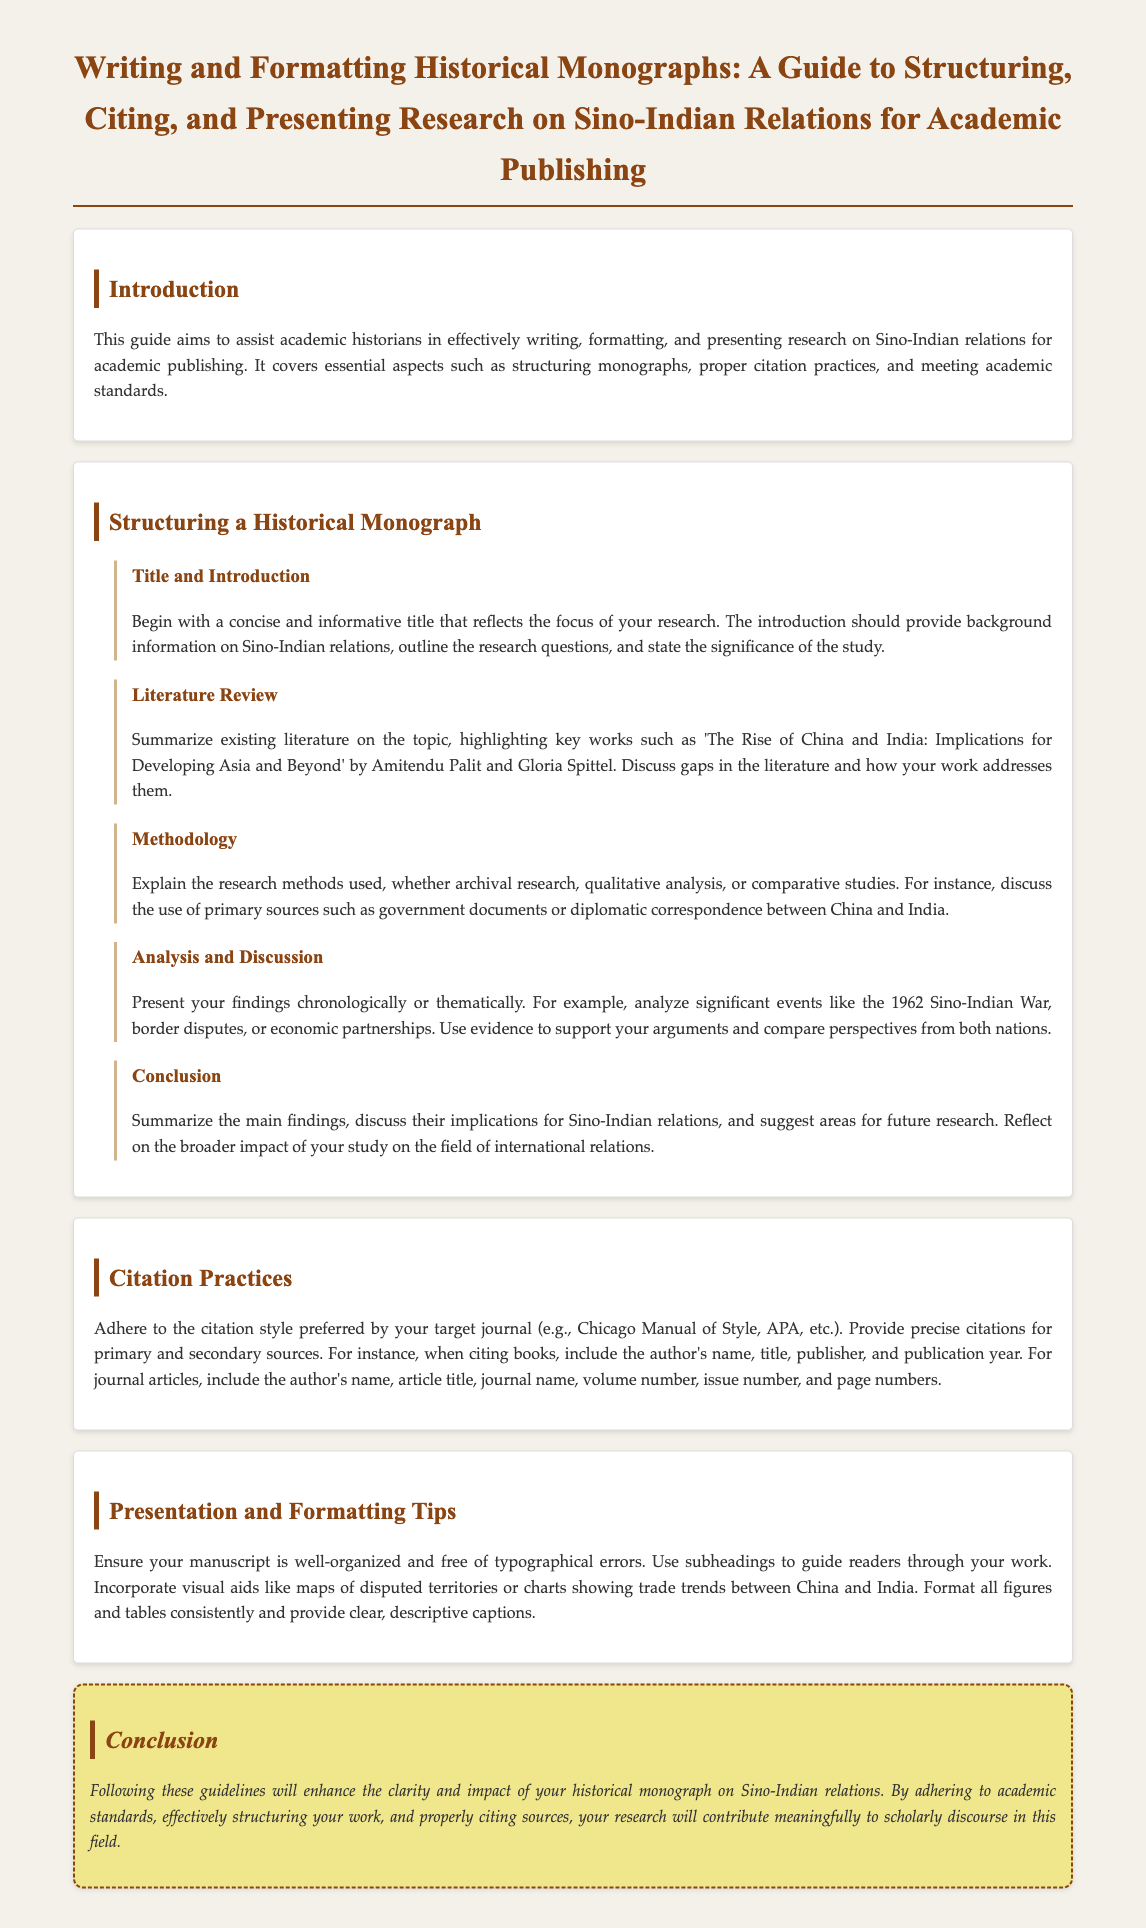What is the title of the guide? The title of the guide is prominently displayed at the top of the document and reflects the focus on historical monographs about Sino-Indian relations.
Answer: Writing and Formatting Historical Monographs: A Guide to Structuring, Citing, and Presenting Research on Sino-Indian Relations for Academic Publishing What should be included in the introduction? The introduction should provide background information on Sino-Indian relations, outline the research questions, and state the significance of the study.
Answer: Background information, research questions, significance What key work is highlighted in the literature review? The literature review summarizes existing literature and mentions a specific key work that focuses on the implications of China and India for developing Asia.
Answer: The Rise of China and India: Implications for Developing Asia and Beyond Which research methods might be discussed in the methodology section? The methodology section refers to several types of research methods used for historical monographs.
Answer: Archival research, qualitative analysis, comparative studies What citation style should be followed? The document specifies that authors should adhere to the citation style preferred by their target journal.
Answer: Chicago Manual of Style, APA What is suggested for the presentation of visual aids? The guide advises incorporating visual aids that help clarify the research findings and enhance the presentation of the historical monograph.
Answer: Maps, charts What should be included in the conclusion section? The conclusion should summarize main findings, discuss implications, and suggest areas for future research.
Answer: Summary of findings, implications, future research areas What type of formatting is suggested for figures and tables? Consistency in formatting is emphasized for figures and tables alongside providing descriptive captions.
Answer: Consistent formatting, clear captions 